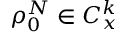Convert formula to latex. <formula><loc_0><loc_0><loc_500><loc_500>\rho _ { 0 } ^ { N } \in C _ { x } ^ { k }</formula> 